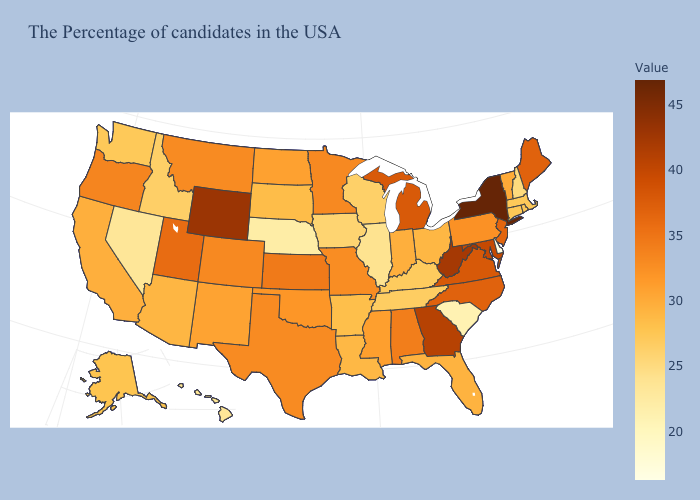Which states have the lowest value in the MidWest?
Be succinct. Nebraska. Does Delaware have the lowest value in the USA?
Concise answer only. Yes. Among the states that border Utah , does Wyoming have the lowest value?
Give a very brief answer. No. 